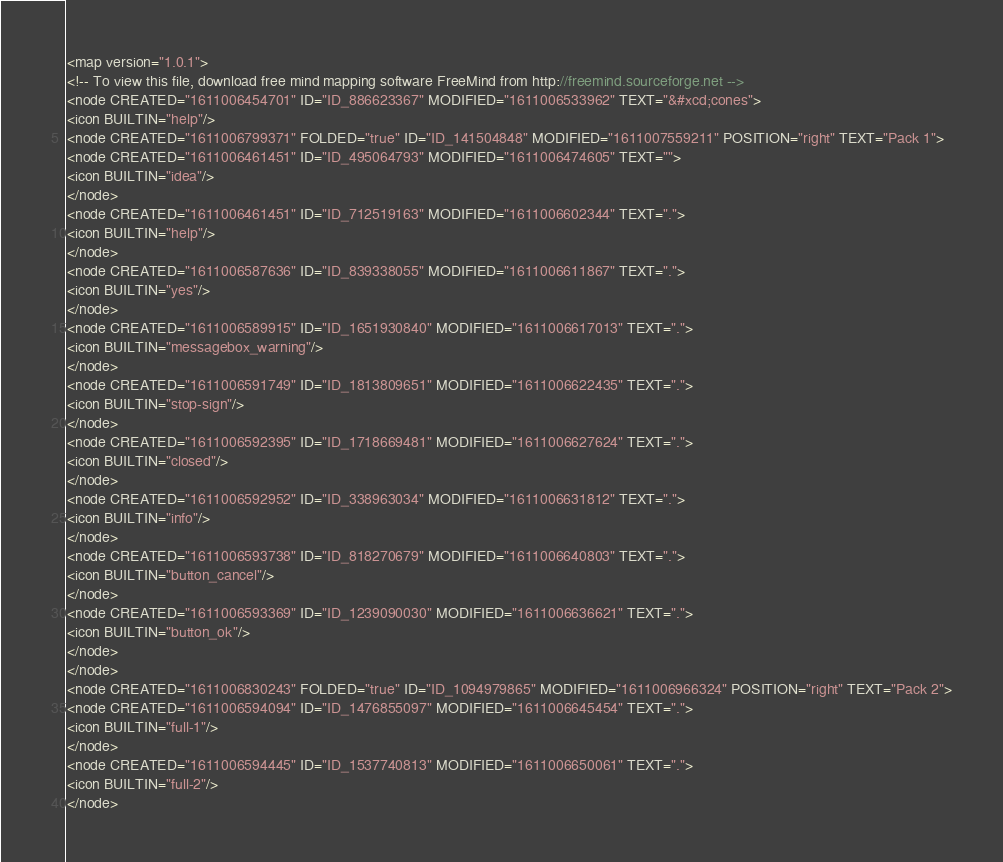<code> <loc_0><loc_0><loc_500><loc_500><_ObjectiveC_><map version="1.0.1">
<!-- To view this file, download free mind mapping software FreeMind from http://freemind.sourceforge.net -->
<node CREATED="1611006454701" ID="ID_886623367" MODIFIED="1611006533962" TEXT="&#xcd;cones">
<icon BUILTIN="help"/>
<node CREATED="1611006799371" FOLDED="true" ID="ID_141504848" MODIFIED="1611007559211" POSITION="right" TEXT="Pack 1">
<node CREATED="1611006461451" ID="ID_495064793" MODIFIED="1611006474605" TEXT="">
<icon BUILTIN="idea"/>
</node>
<node CREATED="1611006461451" ID="ID_712519163" MODIFIED="1611006602344" TEXT=".">
<icon BUILTIN="help"/>
</node>
<node CREATED="1611006587636" ID="ID_839338055" MODIFIED="1611006611867" TEXT=".">
<icon BUILTIN="yes"/>
</node>
<node CREATED="1611006589915" ID="ID_1651930840" MODIFIED="1611006617013" TEXT=".">
<icon BUILTIN="messagebox_warning"/>
</node>
<node CREATED="1611006591749" ID="ID_1813809651" MODIFIED="1611006622435" TEXT=".">
<icon BUILTIN="stop-sign"/>
</node>
<node CREATED="1611006592395" ID="ID_1718669481" MODIFIED="1611006627624" TEXT=".">
<icon BUILTIN="closed"/>
</node>
<node CREATED="1611006592952" ID="ID_338963034" MODIFIED="1611006631812" TEXT=".">
<icon BUILTIN="info"/>
</node>
<node CREATED="1611006593738" ID="ID_818270679" MODIFIED="1611006640803" TEXT=".">
<icon BUILTIN="button_cancel"/>
</node>
<node CREATED="1611006593369" ID="ID_1239090030" MODIFIED="1611006636621" TEXT=".">
<icon BUILTIN="button_ok"/>
</node>
</node>
<node CREATED="1611006830243" FOLDED="true" ID="ID_1094979865" MODIFIED="1611006966324" POSITION="right" TEXT="Pack 2">
<node CREATED="1611006594094" ID="ID_1476855097" MODIFIED="1611006645454" TEXT=".">
<icon BUILTIN="full-1"/>
</node>
<node CREATED="1611006594445" ID="ID_1537740813" MODIFIED="1611006650061" TEXT=".">
<icon BUILTIN="full-2"/>
</node></code> 